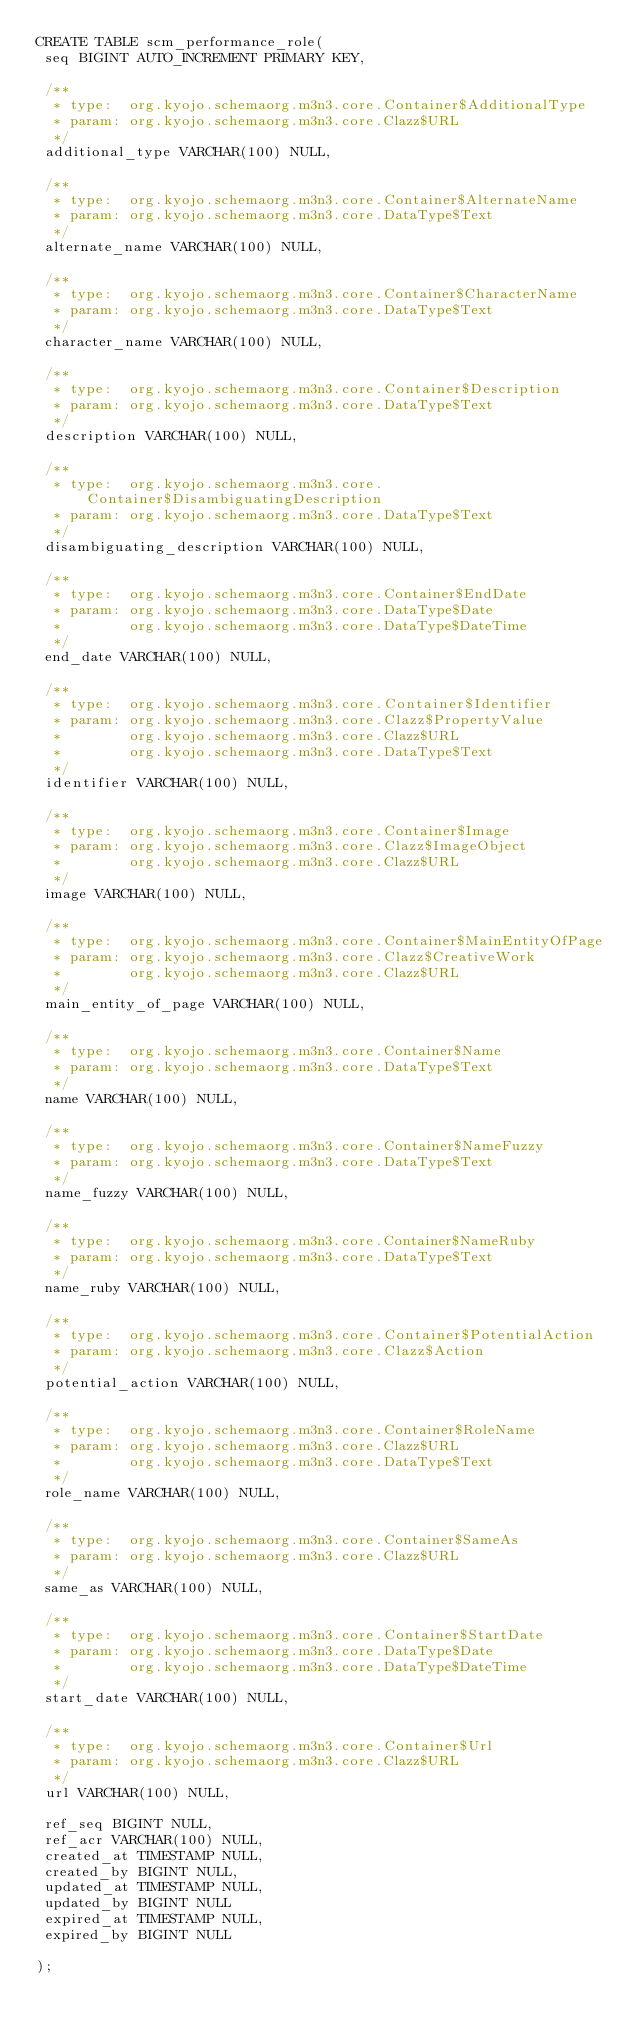Convert code to text. <code><loc_0><loc_0><loc_500><loc_500><_SQL_>CREATE TABLE scm_performance_role(
 seq BIGINT AUTO_INCREMENT PRIMARY KEY,

 /**
  * type:  org.kyojo.schemaorg.m3n3.core.Container$AdditionalType
  * param: org.kyojo.schemaorg.m3n3.core.Clazz$URL
  */
 additional_type VARCHAR(100) NULL,

 /**
  * type:  org.kyojo.schemaorg.m3n3.core.Container$AlternateName
  * param: org.kyojo.schemaorg.m3n3.core.DataType$Text
  */
 alternate_name VARCHAR(100) NULL,

 /**
  * type:  org.kyojo.schemaorg.m3n3.core.Container$CharacterName
  * param: org.kyojo.schemaorg.m3n3.core.DataType$Text
  */
 character_name VARCHAR(100) NULL,

 /**
  * type:  org.kyojo.schemaorg.m3n3.core.Container$Description
  * param: org.kyojo.schemaorg.m3n3.core.DataType$Text
  */
 description VARCHAR(100) NULL,

 /**
  * type:  org.kyojo.schemaorg.m3n3.core.Container$DisambiguatingDescription
  * param: org.kyojo.schemaorg.m3n3.core.DataType$Text
  */
 disambiguating_description VARCHAR(100) NULL,

 /**
  * type:  org.kyojo.schemaorg.m3n3.core.Container$EndDate
  * param: org.kyojo.schemaorg.m3n3.core.DataType$Date
  *        org.kyojo.schemaorg.m3n3.core.DataType$DateTime
  */
 end_date VARCHAR(100) NULL,

 /**
  * type:  org.kyojo.schemaorg.m3n3.core.Container$Identifier
  * param: org.kyojo.schemaorg.m3n3.core.Clazz$PropertyValue
  *        org.kyojo.schemaorg.m3n3.core.Clazz$URL
  *        org.kyojo.schemaorg.m3n3.core.DataType$Text
  */
 identifier VARCHAR(100) NULL,

 /**
  * type:  org.kyojo.schemaorg.m3n3.core.Container$Image
  * param: org.kyojo.schemaorg.m3n3.core.Clazz$ImageObject
  *        org.kyojo.schemaorg.m3n3.core.Clazz$URL
  */
 image VARCHAR(100) NULL,

 /**
  * type:  org.kyojo.schemaorg.m3n3.core.Container$MainEntityOfPage
  * param: org.kyojo.schemaorg.m3n3.core.Clazz$CreativeWork
  *        org.kyojo.schemaorg.m3n3.core.Clazz$URL
  */
 main_entity_of_page VARCHAR(100) NULL,

 /**
  * type:  org.kyojo.schemaorg.m3n3.core.Container$Name
  * param: org.kyojo.schemaorg.m3n3.core.DataType$Text
  */
 name VARCHAR(100) NULL,

 /**
  * type:  org.kyojo.schemaorg.m3n3.core.Container$NameFuzzy
  * param: org.kyojo.schemaorg.m3n3.core.DataType$Text
  */
 name_fuzzy VARCHAR(100) NULL,

 /**
  * type:  org.kyojo.schemaorg.m3n3.core.Container$NameRuby
  * param: org.kyojo.schemaorg.m3n3.core.DataType$Text
  */
 name_ruby VARCHAR(100) NULL,

 /**
  * type:  org.kyojo.schemaorg.m3n3.core.Container$PotentialAction
  * param: org.kyojo.schemaorg.m3n3.core.Clazz$Action
  */
 potential_action VARCHAR(100) NULL,

 /**
  * type:  org.kyojo.schemaorg.m3n3.core.Container$RoleName
  * param: org.kyojo.schemaorg.m3n3.core.Clazz$URL
  *        org.kyojo.schemaorg.m3n3.core.DataType$Text
  */
 role_name VARCHAR(100) NULL,

 /**
  * type:  org.kyojo.schemaorg.m3n3.core.Container$SameAs
  * param: org.kyojo.schemaorg.m3n3.core.Clazz$URL
  */
 same_as VARCHAR(100) NULL,

 /**
  * type:  org.kyojo.schemaorg.m3n3.core.Container$StartDate
  * param: org.kyojo.schemaorg.m3n3.core.DataType$Date
  *        org.kyojo.schemaorg.m3n3.core.DataType$DateTime
  */
 start_date VARCHAR(100) NULL,

 /**
  * type:  org.kyojo.schemaorg.m3n3.core.Container$Url
  * param: org.kyojo.schemaorg.m3n3.core.Clazz$URL
  */
 url VARCHAR(100) NULL,

 ref_seq BIGINT NULL,
 ref_acr VARCHAR(100) NULL,
 created_at TIMESTAMP NULL,
 created_by BIGINT NULL,
 updated_at TIMESTAMP NULL,
 updated_by BIGINT NULL
 expired_at TIMESTAMP NULL,
 expired_by BIGINT NULL

);</code> 